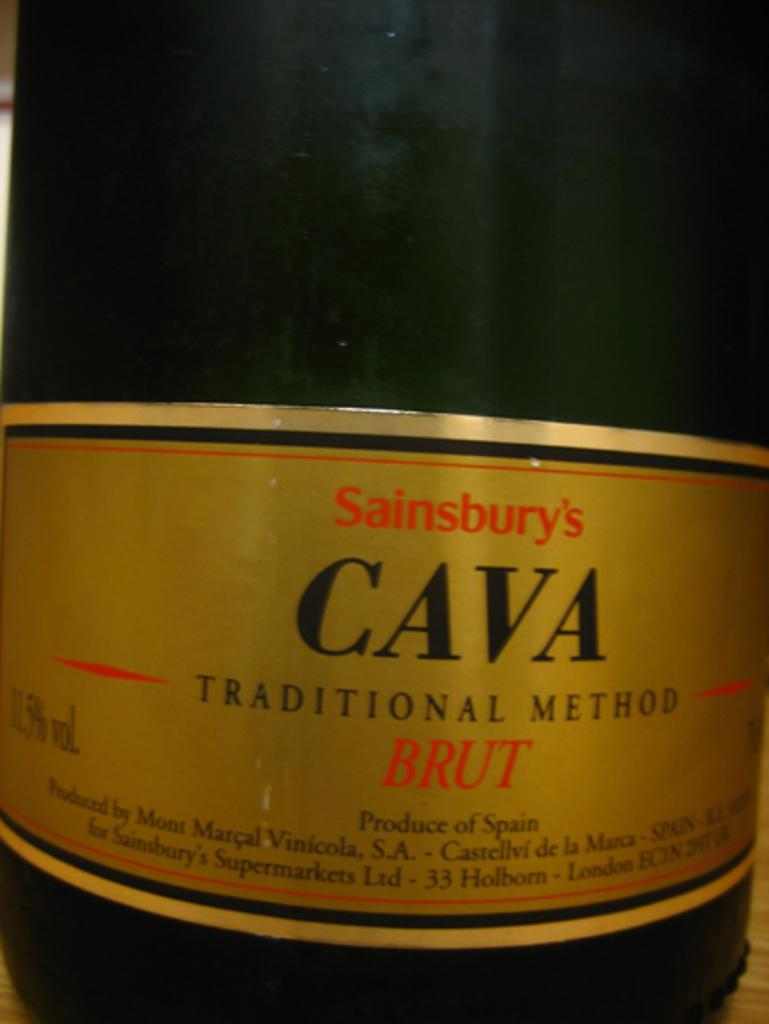<image>
Share a concise interpretation of the image provided. A bottle of Sainsbury's Cava done by the traditional method. 